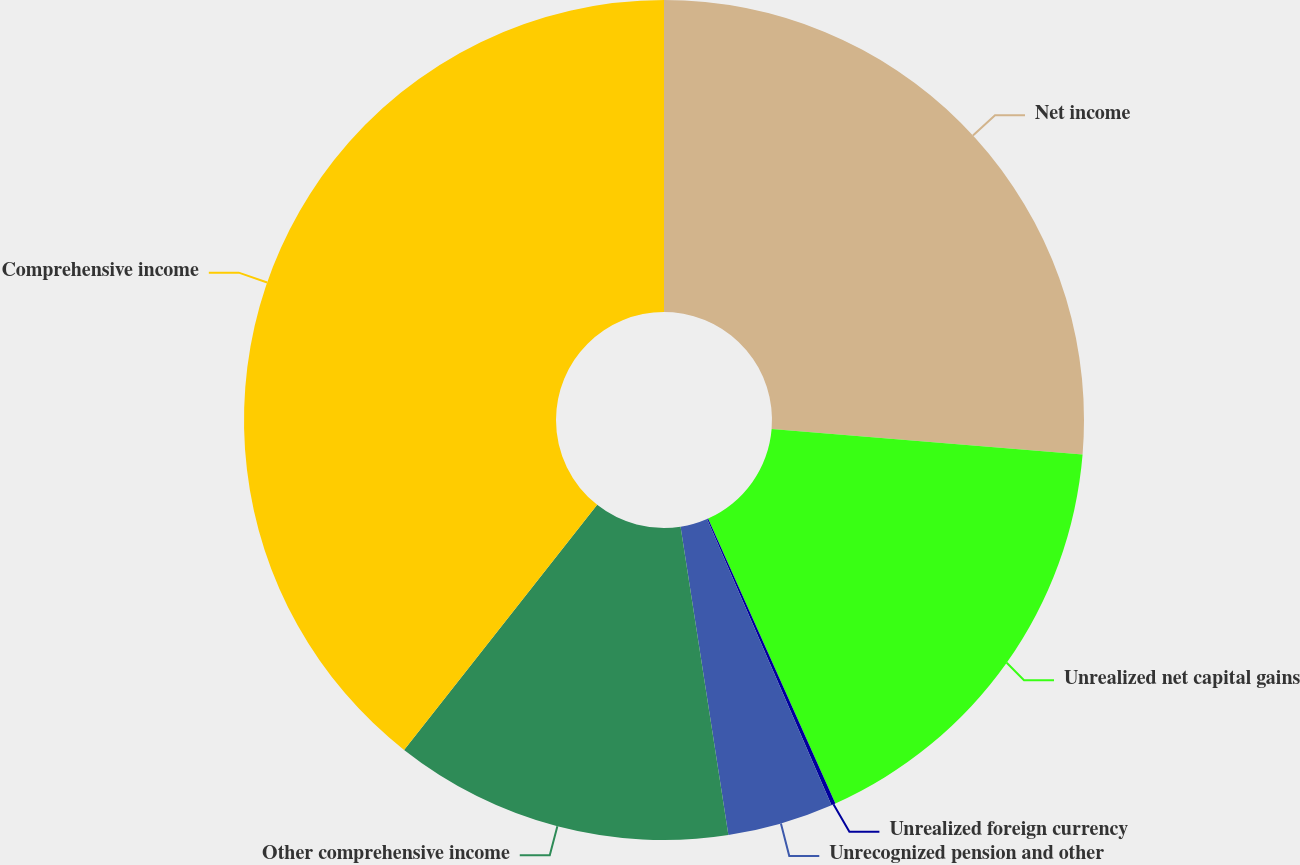<chart> <loc_0><loc_0><loc_500><loc_500><pie_chart><fcel>Net income<fcel>Unrealized net capital gains<fcel>Unrealized foreign currency<fcel>Unrecognized pension and other<fcel>Other comprehensive income<fcel>Comprehensive income<nl><fcel>26.31%<fcel>17.0%<fcel>0.16%<fcel>4.08%<fcel>13.07%<fcel>39.38%<nl></chart> 